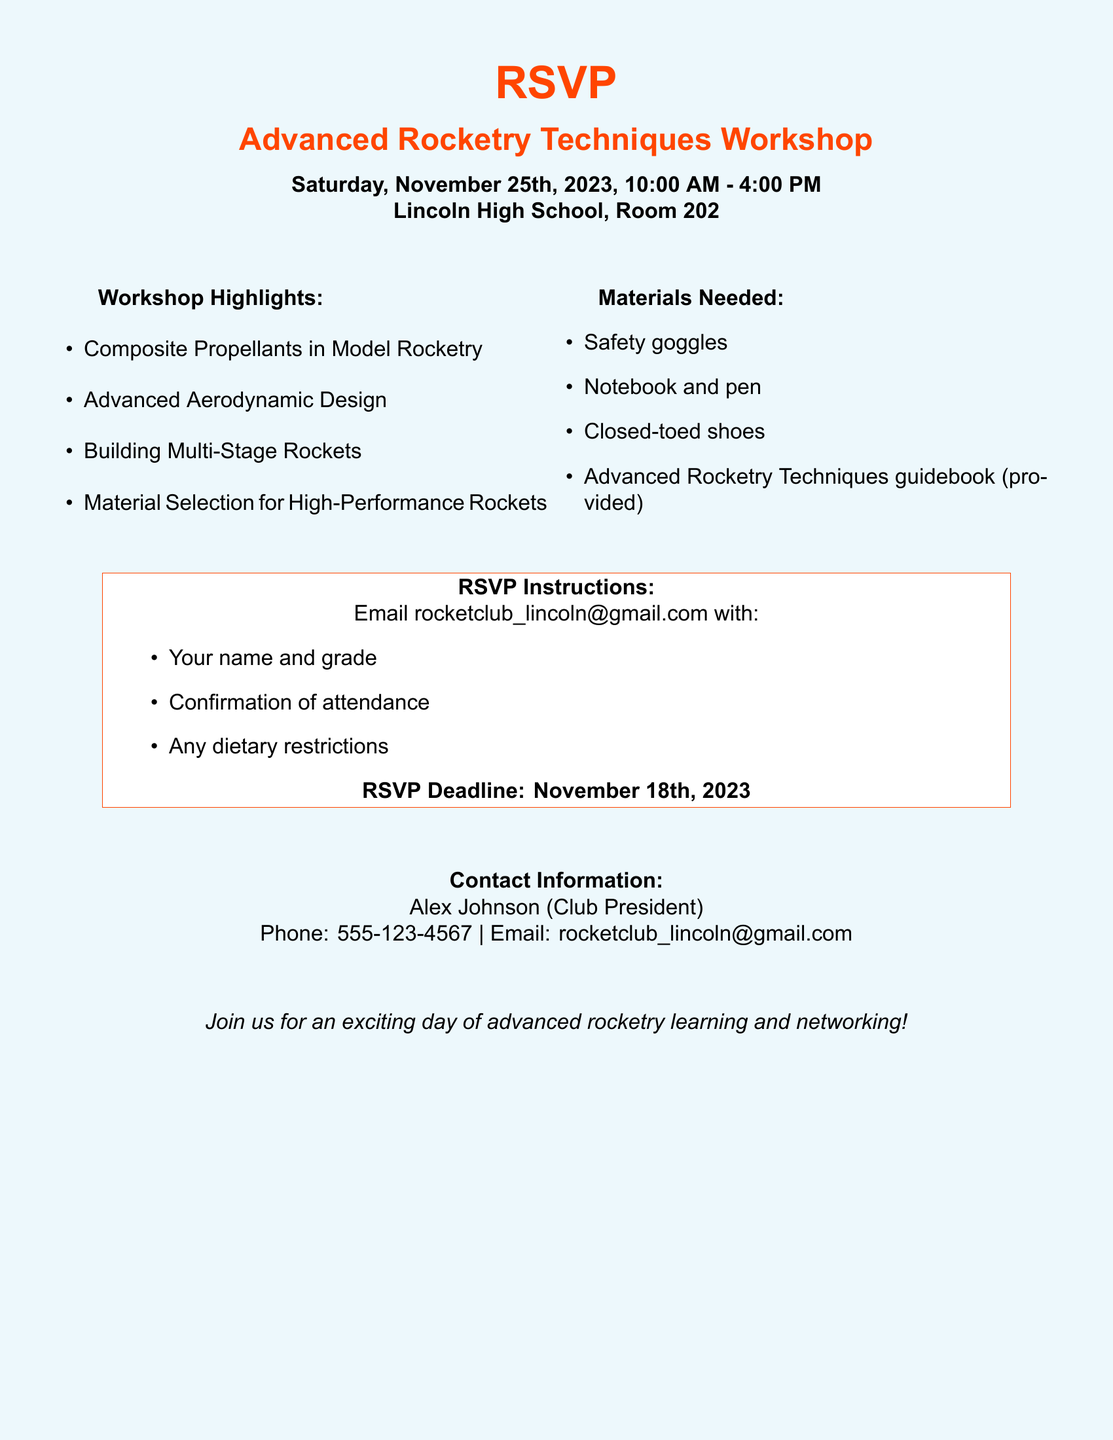What is the date of the workshop? The date of the workshop is explicitly stated in the document as Saturday, November 25th, 2023.
Answer: Saturday, November 25th, 2023 What time does the workshop start? The start time is mentioned directly, which is 10:00 AM.
Answer: 10:00 AM Who should be contacted for more information? The document provides contact details for Alex Johnson, who is the Club President.
Answer: Alex Johnson What materials are needed for the workshop? The document lists specific materials needed, such as safety goggles and a notebook.
Answer: Safety goggles What is the RSVP deadline? The RSVP deadline is clearly indicated in the document as November 18th, 2023.
Answer: November 18th, 2023 What is one of the workshop highlights? The workshop highlights include topics such as Composite Propellants in Model Rocketry, which is mentioned in the highlights list.
Answer: Composite Propellants in Model Rocketry How can attendees confirm their attendance? Attendees are instructed to email a specific address with their name and other details to confirm.
Answer: Email rocketclub_lincoln@gmail.com What type of shoes are required for the workshop? The document specifies that attendees must wear closed-toed shoes.
Answer: Closed-toed shoes 